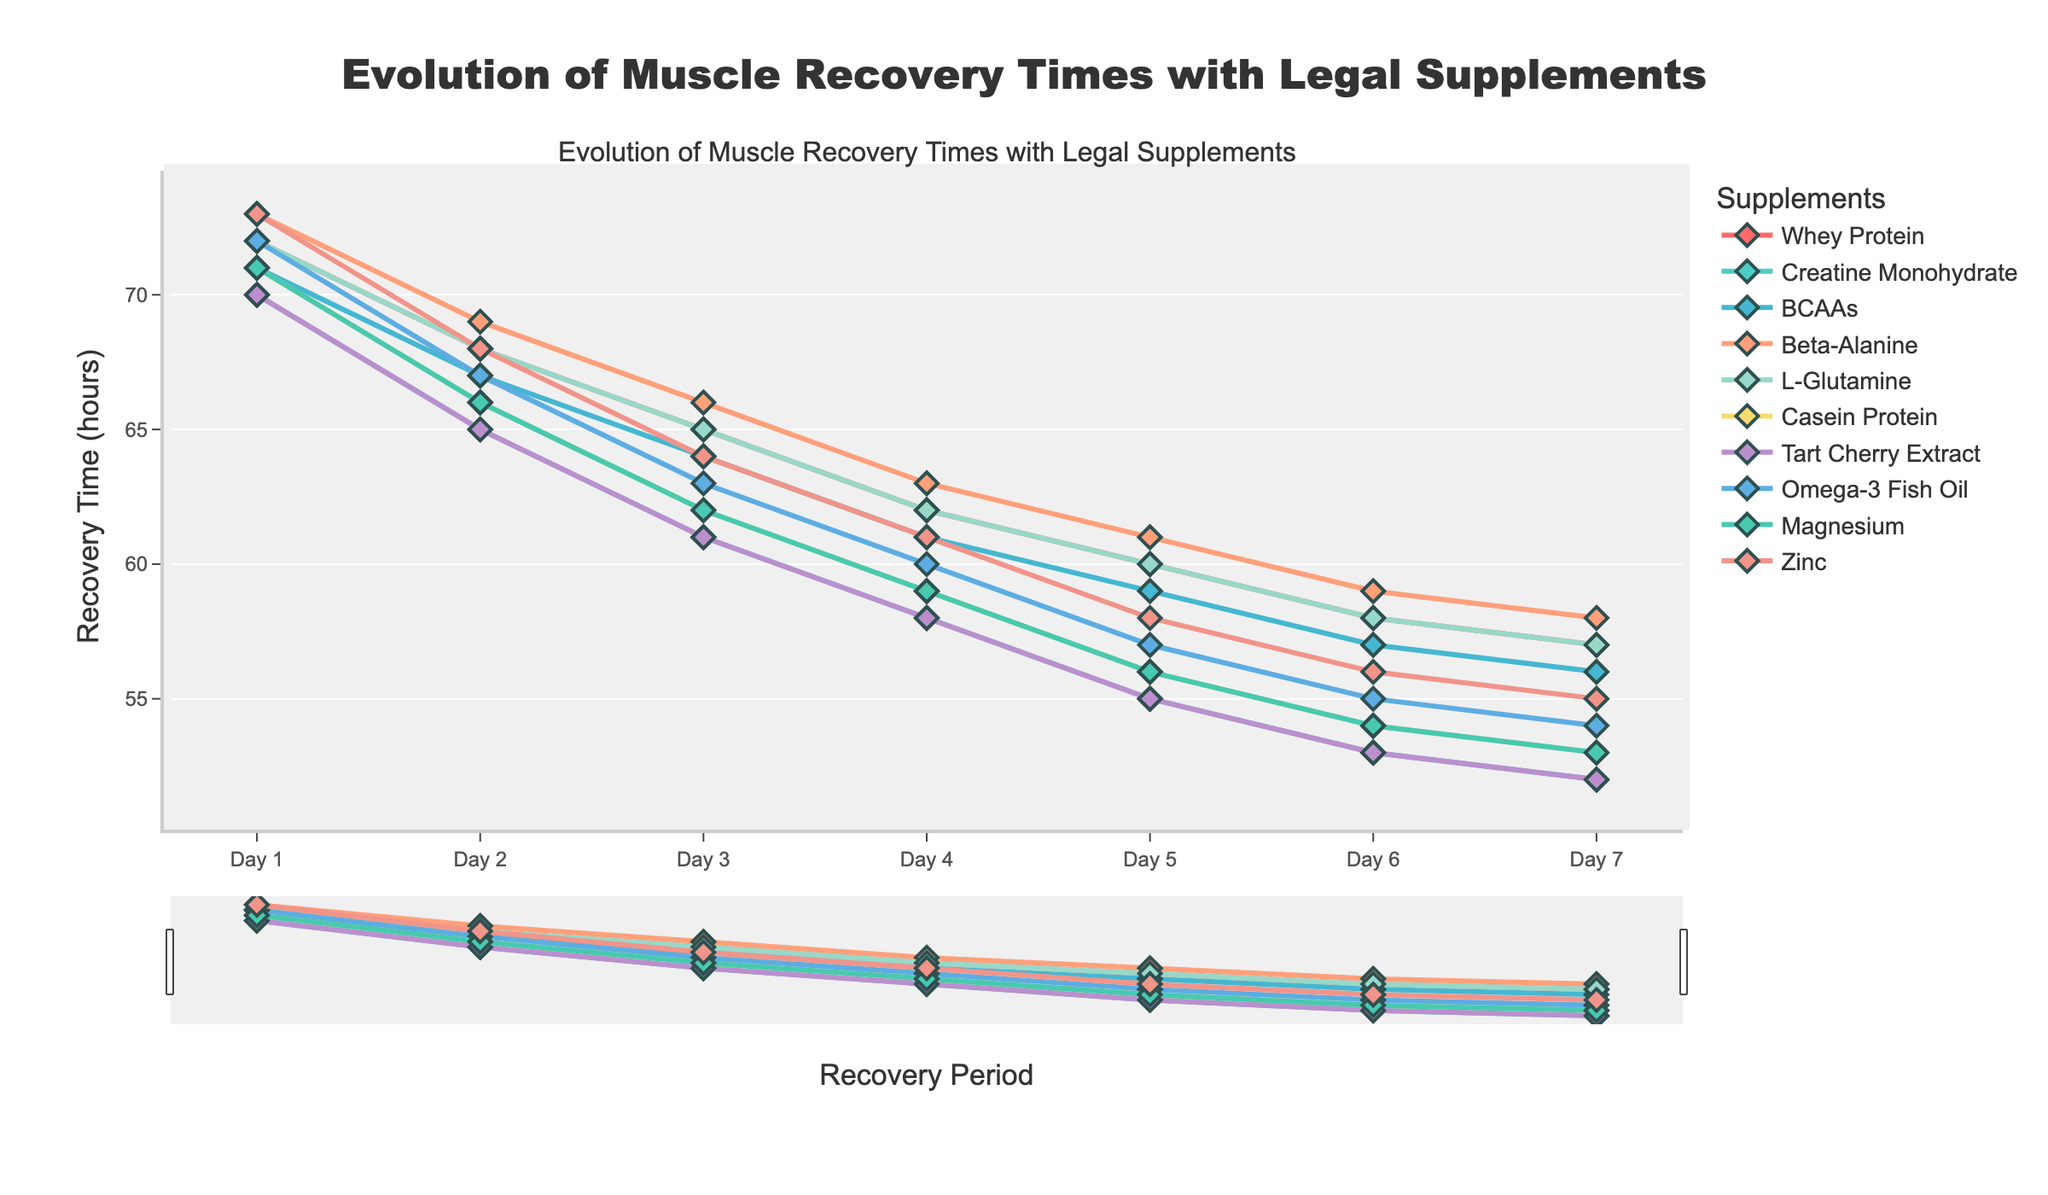What's the trend in muscle recovery time for athletes using Omega-3 Fish Oil? In the figure, we see that Omega-3 Fish Oil starts with a recovery time of 72 hours on Day 1 and gradually decreases to 54 hours by Day 7. This shows a consistent improvement in recovery time over the week.
Answer: Consistent decrease Which supplement shows the fastest recovery by Day 7? By observing the figure, it is clear that both Creatine Monohydrate and Tart Cherry Extract result in the same recovery time of 52 hours on Day 7, both being the lowest among all supplements on that day.
Answer: Creatine Monohydrate and Tart Cherry Extract Which supplement shows no difference in recovery time on Day 7 compared to Day 1? A thorough comparison of the recovery times for all supplements reveals that none show no difference at all. All supplements have improved recovery times by Day 7 compared to Day 1.
Answer: None How does the recovery time of BCAAs on Day 4 compare to that of Casein Protein on Day 4? On Day 4, BCAAs have a recovery time of 61 hours, while Casein Protein has a recovery time of 59 hours. Comparing these, we see Casein Protein has a slightly faster recovery time by 2 hours.
Answer: Casein Protein is 2 hours faster What's the average recovery time on Day 3 for all supplements? Summing the recovery times for all supplements on Day 3 (65, 61, 64, 66, 65, 62, 61, 63, 62, 64) gives us 633 hours. There are 10 supplements, so the average recovery time is 633/10 = 63.3 hours.
Answer: 63.3 hours Which supplements intersect in recovery time on Day 6, and what is that time? Observing the figure, we see that Whey Protein and L-Glutamine intersect at the same recovery time of 58 hours on Day 6.
Answer: Whey Protein and L-Glutamine at 58 hours What is the difference in recovery time between Zinc and Magnesium on Day 5? On Day 5, Zinc has a recovery time of 58 hours, while Magnesium has a recovery time of 56 hours. The difference is 58 - 56 = 2 hours.
Answer: 2 hours How does the slope of the recovery time trend for Beta-Alanine compare to Whey Protein from Day 2 to Day 4? Beta-Alanine decreases from 69 to 63 hours (69 - 63 = 6 hours), while Whey Protein decreases from 68 to 62 hours (68 - 62 = 6 hours). Both supplements have the same rate of decline.
Answer: Same rate of decline Which supplement showed the least improvement in muscle recovery time from Day 1 to Day 7? From the figure, Beta-Alanine shows a change from 73 hours on Day 1 to 58 hours on Day 7, an improvement of 15 hours, which is the smallest among all supplements.
Answer: Beta-Alanine 